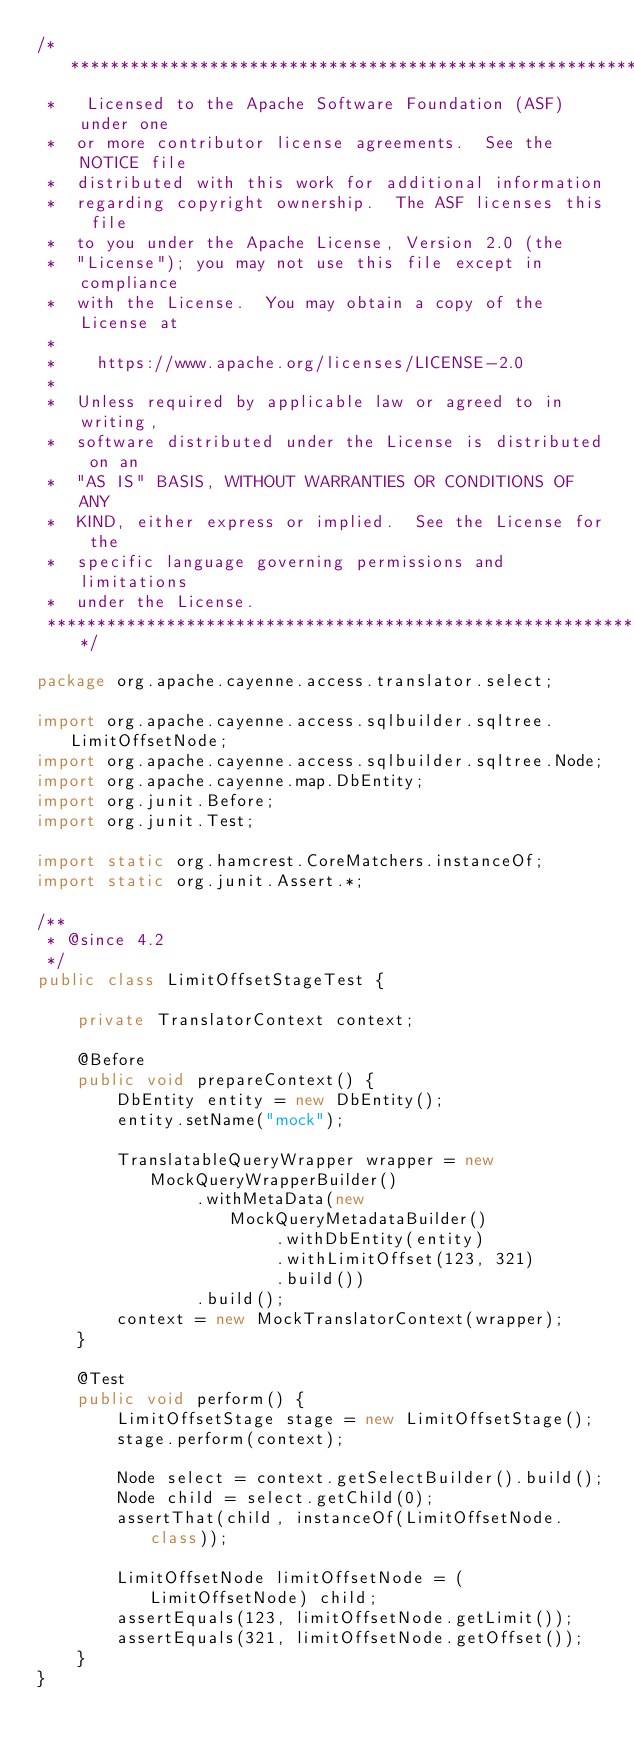Convert code to text. <code><loc_0><loc_0><loc_500><loc_500><_Java_>/*****************************************************************
 *   Licensed to the Apache Software Foundation (ASF) under one
 *  or more contributor license agreements.  See the NOTICE file
 *  distributed with this work for additional information
 *  regarding copyright ownership.  The ASF licenses this file
 *  to you under the Apache License, Version 2.0 (the
 *  "License"); you may not use this file except in compliance
 *  with the License.  You may obtain a copy of the License at
 *
 *    https://www.apache.org/licenses/LICENSE-2.0
 *
 *  Unless required by applicable law or agreed to in writing,
 *  software distributed under the License is distributed on an
 *  "AS IS" BASIS, WITHOUT WARRANTIES OR CONDITIONS OF ANY
 *  KIND, either express or implied.  See the License for the
 *  specific language governing permissions and limitations
 *  under the License.
 ****************************************************************/

package org.apache.cayenne.access.translator.select;

import org.apache.cayenne.access.sqlbuilder.sqltree.LimitOffsetNode;
import org.apache.cayenne.access.sqlbuilder.sqltree.Node;
import org.apache.cayenne.map.DbEntity;
import org.junit.Before;
import org.junit.Test;

import static org.hamcrest.CoreMatchers.instanceOf;
import static org.junit.Assert.*;

/**
 * @since 4.2
 */
public class LimitOffsetStageTest {

    private TranslatorContext context;

    @Before
    public void prepareContext() {
        DbEntity entity = new DbEntity();
        entity.setName("mock");

        TranslatableQueryWrapper wrapper = new MockQueryWrapperBuilder()
                .withMetaData(new MockQueryMetadataBuilder()
                        .withDbEntity(entity)
                        .withLimitOffset(123, 321)
                        .build())
                .build();
        context = new MockTranslatorContext(wrapper);
    }

    @Test
    public void perform() {
        LimitOffsetStage stage = new LimitOffsetStage();
        stage.perform(context);

        Node select = context.getSelectBuilder().build();
        Node child = select.getChild(0);
        assertThat(child, instanceOf(LimitOffsetNode.class));

        LimitOffsetNode limitOffsetNode = (LimitOffsetNode) child;
        assertEquals(123, limitOffsetNode.getLimit());
        assertEquals(321, limitOffsetNode.getOffset());
    }
}</code> 